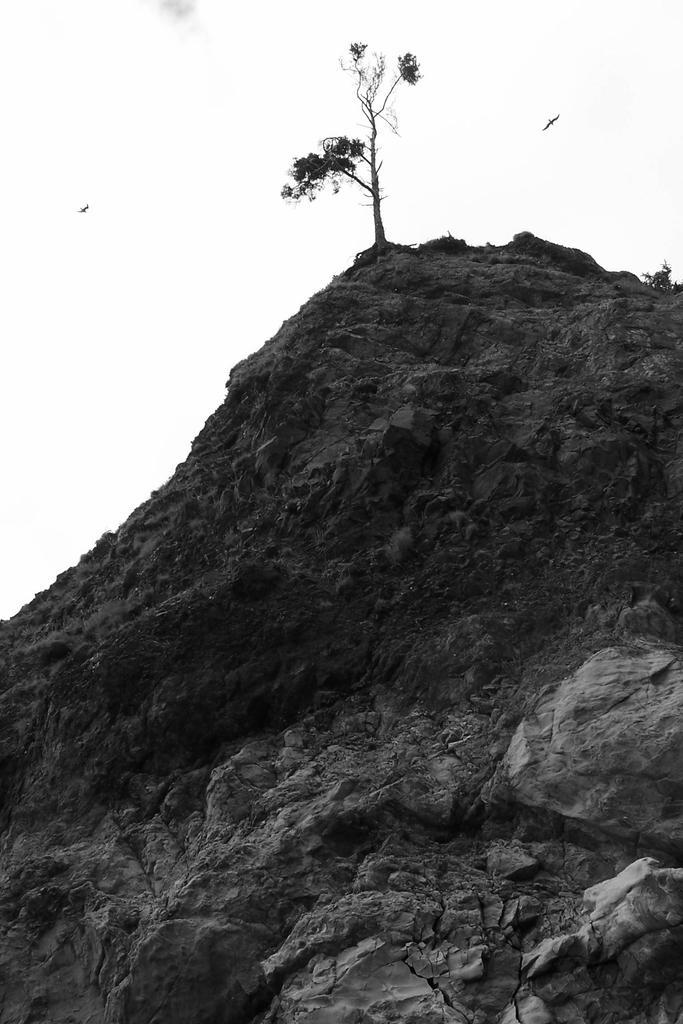Please provide a concise description of this image. This is a black and white image. On the hill there are rocks. On the top of the hill there is a tree. In the background there is sky. 